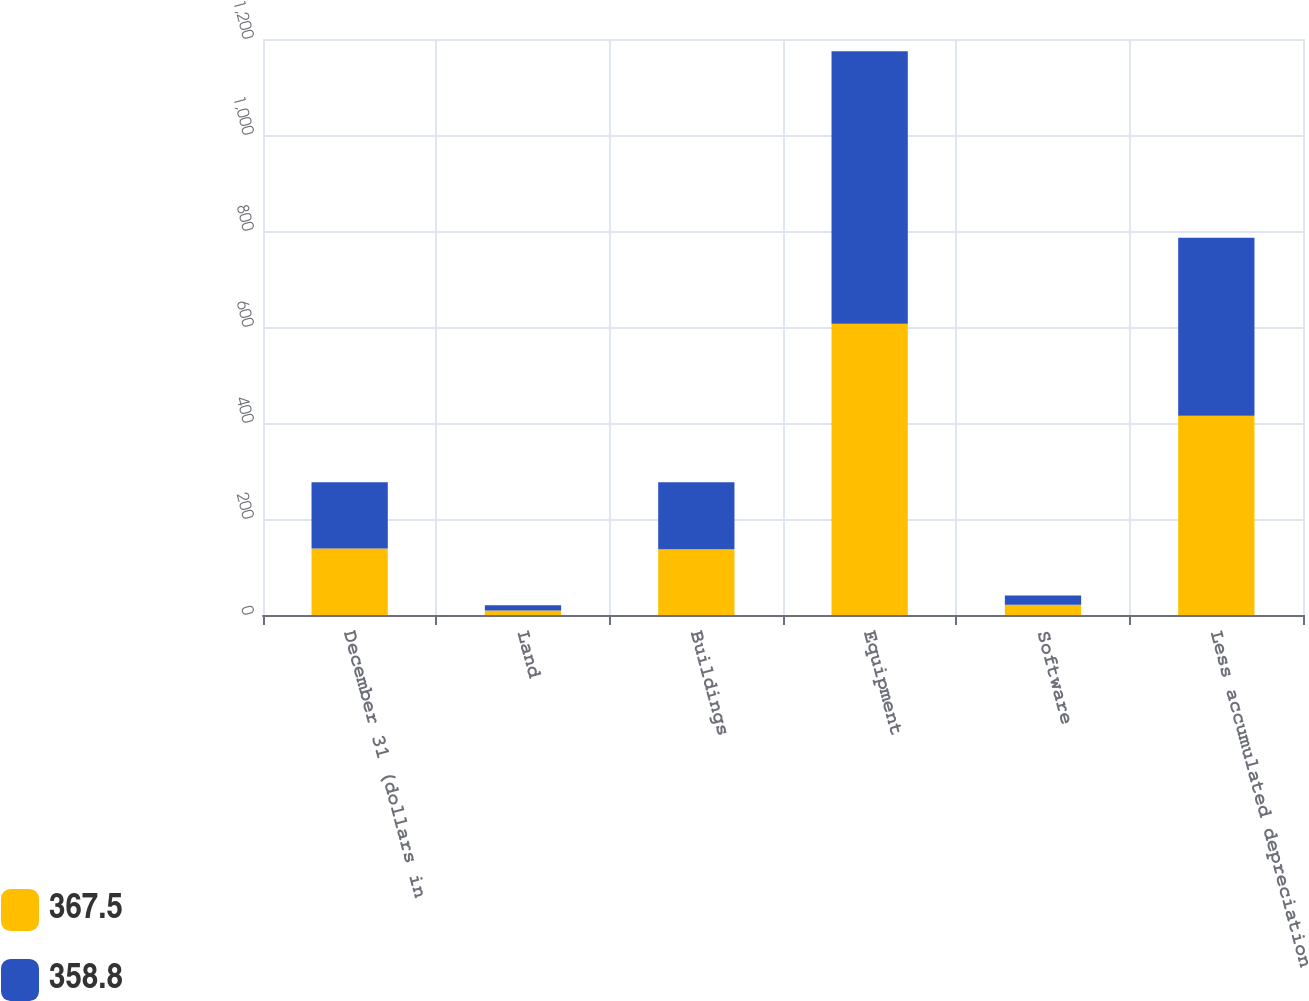Convert chart to OTSL. <chart><loc_0><loc_0><loc_500><loc_500><stacked_bar_chart><ecel><fcel>December 31 (dollars in<fcel>Land<fcel>Buildings<fcel>Equipment<fcel>Software<fcel>Less accumulated depreciation<nl><fcel>367.5<fcel>138.4<fcel>9.3<fcel>136.8<fcel>606.6<fcel>21.1<fcel>415<nl><fcel>358.8<fcel>138.4<fcel>10.9<fcel>140<fcel>568<fcel>19.4<fcel>370.8<nl></chart> 